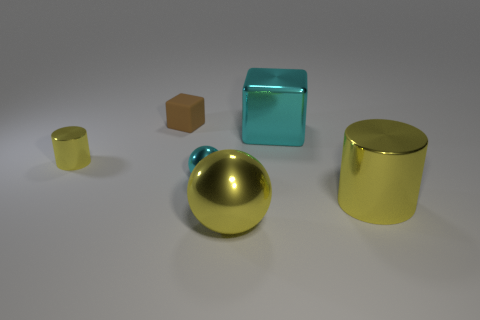Subtract all cylinders. How many objects are left? 4 Add 3 large metal balls. How many objects exist? 9 Add 2 metal cylinders. How many metal cylinders are left? 4 Add 1 big shiny objects. How many big shiny objects exist? 4 Subtract 0 blue cylinders. How many objects are left? 6 Subtract all big metal cylinders. Subtract all large yellow metal balls. How many objects are left? 4 